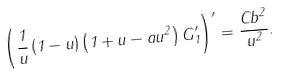Convert formula to latex. <formula><loc_0><loc_0><loc_500><loc_500>\left ( \frac { 1 } { u } \left ( 1 - u \right ) \left ( 1 + u - a u ^ { 2 } \right ) G _ { 1 } ^ { \prime } \right ) ^ { \prime } = \frac { C b ^ { 2 } } { u ^ { 2 } } .</formula> 